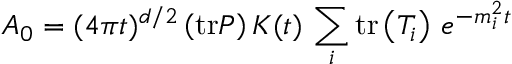Convert formula to latex. <formula><loc_0><loc_0><loc_500><loc_500>A _ { 0 } = ( 4 \pi t ) ^ { d / 2 } \left ( t r P \right ) K ( t ) \, \sum _ { i } t r \left ( T _ { i } \right ) \, e ^ { - m _ { i } ^ { 2 } t }</formula> 